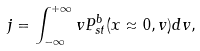Convert formula to latex. <formula><loc_0><loc_0><loc_500><loc_500>j = \int _ { - \infty } ^ { + \infty } v P _ { s t } ^ { b } ( x \approx 0 , v ) d v ,</formula> 